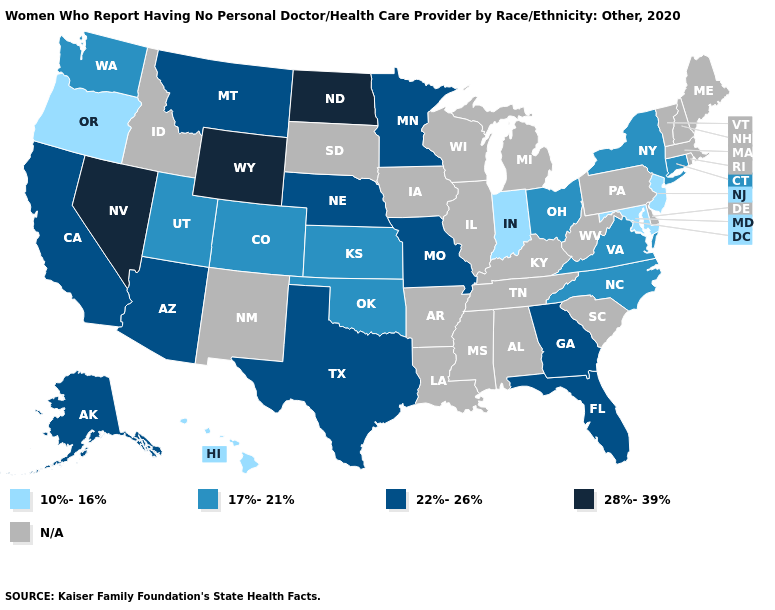Which states have the lowest value in the MidWest?
Answer briefly. Indiana. Name the states that have a value in the range N/A?
Give a very brief answer. Alabama, Arkansas, Delaware, Idaho, Illinois, Iowa, Kentucky, Louisiana, Maine, Massachusetts, Michigan, Mississippi, New Hampshire, New Mexico, Pennsylvania, Rhode Island, South Carolina, South Dakota, Tennessee, Vermont, West Virginia, Wisconsin. Does Virginia have the highest value in the USA?
Short answer required. No. What is the value of Maine?
Be succinct. N/A. Which states have the lowest value in the MidWest?
Answer briefly. Indiana. Among the states that border West Virginia , which have the highest value?
Keep it brief. Ohio, Virginia. Name the states that have a value in the range 22%-26%?
Write a very short answer. Alaska, Arizona, California, Florida, Georgia, Minnesota, Missouri, Montana, Nebraska, Texas. What is the value of Wyoming?
Short answer required. 28%-39%. What is the value of Wisconsin?
Give a very brief answer. N/A. Name the states that have a value in the range 10%-16%?
Quick response, please. Hawaii, Indiana, Maryland, New Jersey, Oregon. Which states have the lowest value in the USA?
Write a very short answer. Hawaii, Indiana, Maryland, New Jersey, Oregon. Does North Dakota have the highest value in the MidWest?
Answer briefly. Yes. What is the value of Oklahoma?
Concise answer only. 17%-21%. 